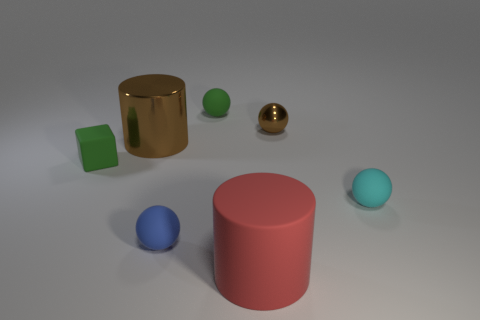What is the shape of the object that is the same color as the cube?
Your answer should be very brief. Sphere. Is the material of the small brown sphere the same as the big red cylinder?
Ensure brevity in your answer.  No. Is the color of the metal cylinder the same as the large matte cylinder?
Keep it short and to the point. No. What is the material of the thing that is in front of the shiny cylinder and behind the small cyan thing?
Ensure brevity in your answer.  Rubber. Are there fewer green matte balls that are in front of the red cylinder than rubber objects that are right of the brown sphere?
Provide a succinct answer. Yes. How many other things are there of the same size as the brown metal ball?
Provide a succinct answer. 4. Are the big red cylinder and the tiny green object in front of the large metallic object made of the same material?
Make the answer very short. Yes. How many things are either green rubber objects left of the blue thing or brown shiny things to the left of the tiny blue ball?
Your answer should be very brief. 2. What color is the rubber cylinder?
Keep it short and to the point. Red. Are there fewer tiny matte spheres that are to the left of the large shiny object than small rubber balls?
Provide a short and direct response. Yes. 